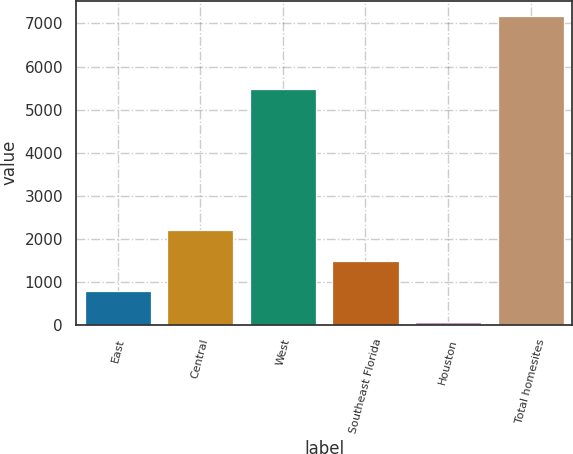Convert chart. <chart><loc_0><loc_0><loc_500><loc_500><bar_chart><fcel>East<fcel>Central<fcel>West<fcel>Southeast Florida<fcel>Houston<fcel>Total homesites<nl><fcel>773.4<fcel>2194.2<fcel>5471<fcel>1483.8<fcel>63<fcel>7167<nl></chart> 